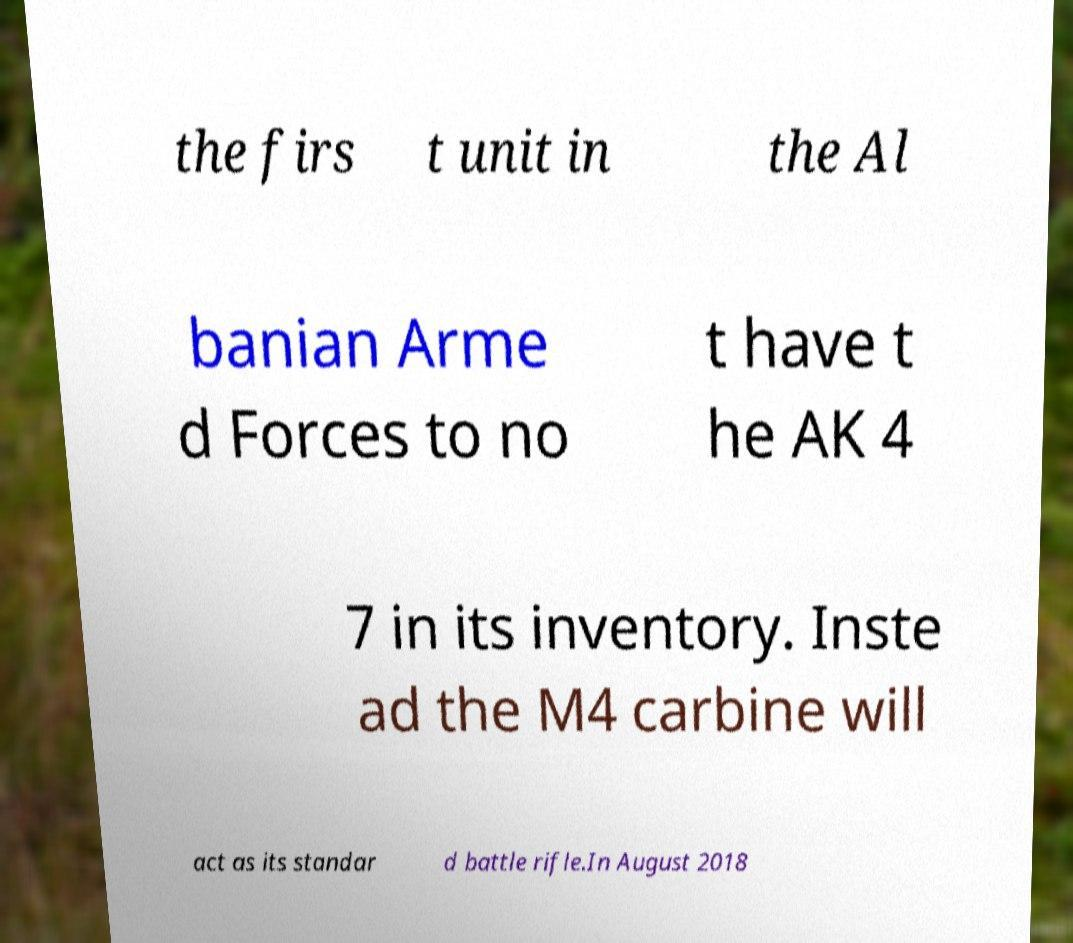Can you accurately transcribe the text from the provided image for me? the firs t unit in the Al banian Arme d Forces to no t have t he AK 4 7 in its inventory. Inste ad the M4 carbine will act as its standar d battle rifle.In August 2018 